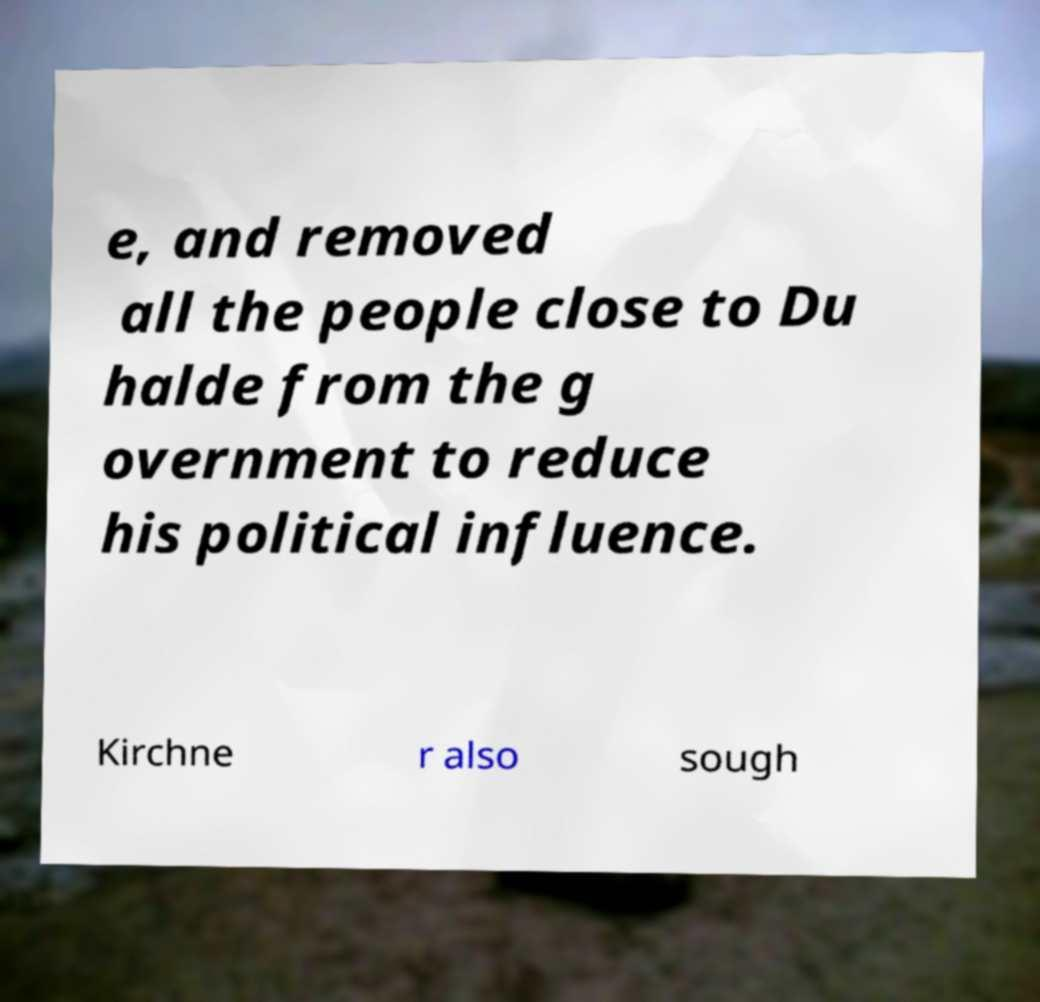Could you extract and type out the text from this image? e, and removed all the people close to Du halde from the g overnment to reduce his political influence. Kirchne r also sough 